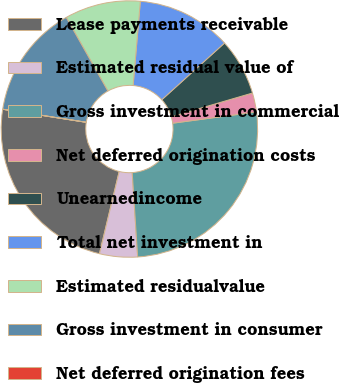<chart> <loc_0><loc_0><loc_500><loc_500><pie_chart><fcel>Lease payments receivable<fcel>Estimated residual value of<fcel>Gross investment in commercial<fcel>Net deferred origination costs<fcel>Unearnedincome<fcel>Total net investment in<fcel>Estimated residualvalue<fcel>Gross investment in consumer<fcel>Net deferred origination fees<nl><fcel>23.71%<fcel>4.78%<fcel>26.1%<fcel>2.4%<fcel>7.17%<fcel>11.94%<fcel>9.56%<fcel>14.33%<fcel>0.01%<nl></chart> 